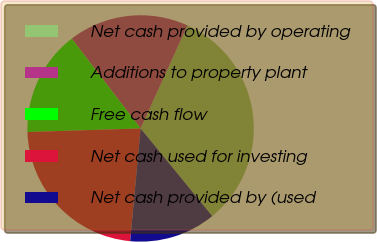Convert chart to OTSL. <chart><loc_0><loc_0><loc_500><loc_500><pie_chart><fcel>Net cash provided by operating<fcel>Additions to property plant<fcel>Free cash flow<fcel>Net cash used for investing<fcel>Net cash provided by (used<nl><fcel>32.3%<fcel>17.2%<fcel>15.09%<fcel>23.02%<fcel>12.38%<nl></chart> 